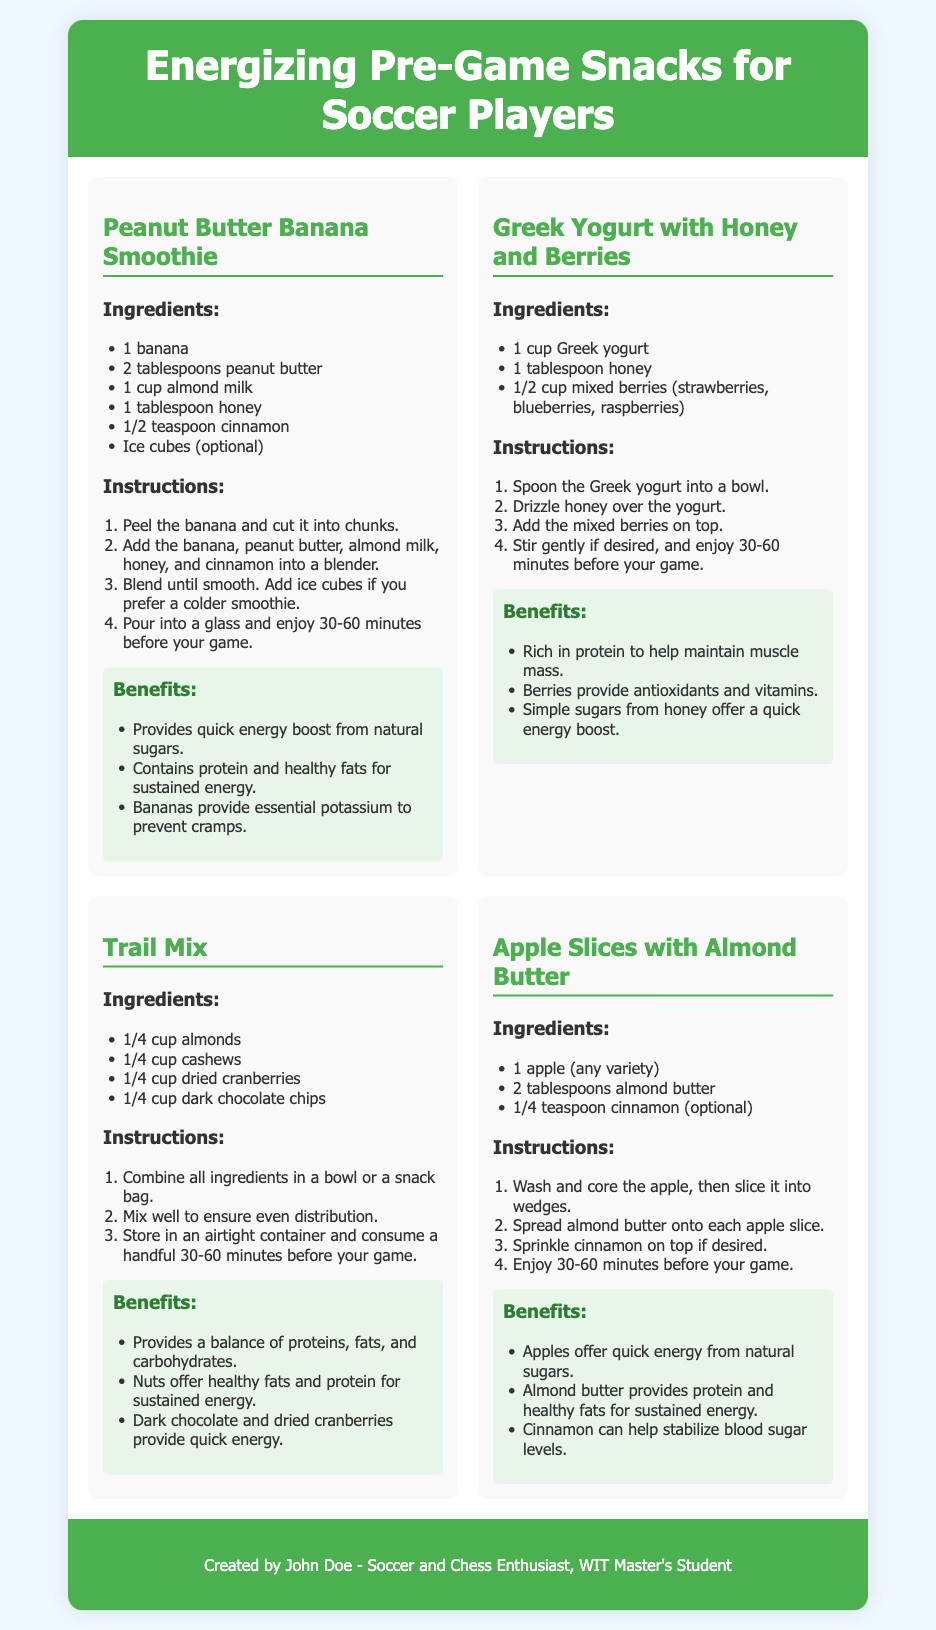What is the first recipe listed? The first recipe presented in the document is "Peanut Butter Banana Smoothie."
Answer: Peanut Butter Banana Smoothie How many tablespoons of peanut butter are needed for the smoothie? The recipe for the Peanut Butter Banana Smoothie specifies the use of 2 tablespoons of peanut butter.
Answer: 2 tablespoons What type of milk is used in the Peanut Butter Banana Smoothie? The recipe calls for almond milk as the milk ingredient in the smoothie.
Answer: Almond milk What are the main benefits of Greek Yogurt with Honey and Berries? This snack provides protein, antioxidants, vitamins, and a quick energy boost from the simple sugars in honey.
Answer: Protein, antioxidants, vitamins, quick energy boost How long before the game should players consume these snacks? The snacks should be enjoyed 30-60 minutes before the game to maximize their energizing effects.
Answer: 30-60 minutes What fruit is used in the Apple Slices with Almond Butter recipe? The recipe indicates that any variety of apple can be used for this snack.
Answer: Apple How many cups of Greek yogurt are needed for the Greek Yogurt with Honey and Berries? The recipe requires 1 cup of Greek yogurt.
Answer: 1 cup What are two ingredients in the Trail Mix recipe? The Trail Mix recipe includes almonds and dried cranberries, among other ingredients.
Answer: Almonds, dried cranberries What is a possible optional ingredient in the Apple Slices with Almond Butter? Cinnamon is mentioned as an optional ingredient to sprinkle on top of the apple slices.
Answer: Cinnamon 